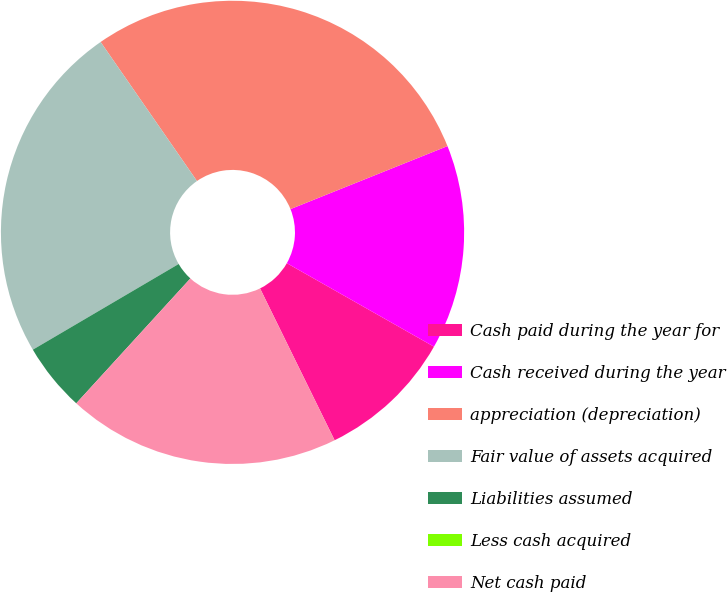Convert chart to OTSL. <chart><loc_0><loc_0><loc_500><loc_500><pie_chart><fcel>Cash paid during the year for<fcel>Cash received during the year<fcel>appreciation (depreciation)<fcel>Fair value of assets acquired<fcel>Liabilities assumed<fcel>Less cash acquired<fcel>Net cash paid<nl><fcel>9.52%<fcel>14.29%<fcel>28.57%<fcel>23.81%<fcel>4.76%<fcel>0.0%<fcel>19.05%<nl></chart> 